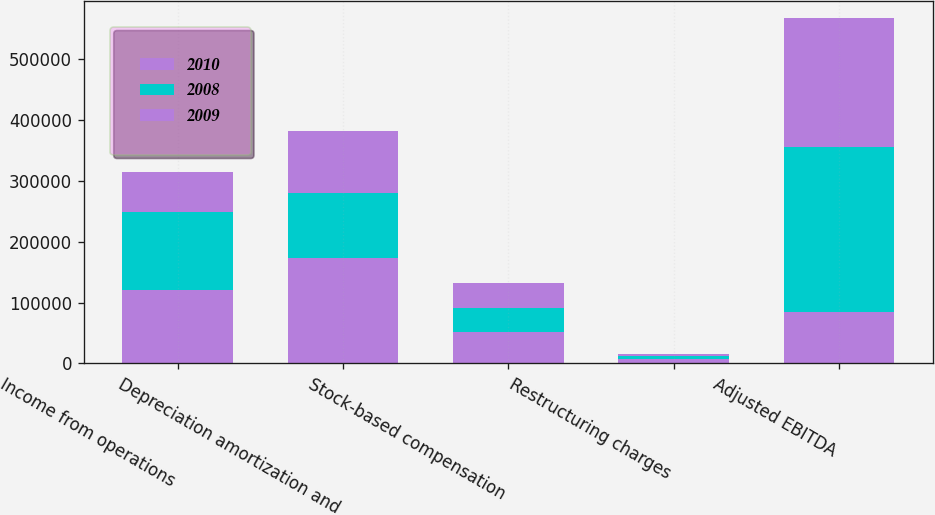Convert chart to OTSL. <chart><loc_0><loc_0><loc_500><loc_500><stacked_bar_chart><ecel><fcel>Income from operations<fcel>Depreciation amortization and<fcel>Stock-based compensation<fcel>Restructuring charges<fcel>Adjusted EBITDA<nl><fcel>2010<fcel>121118<fcel>173811<fcel>50966<fcel>6734<fcel>83808<nl><fcel>2008<fcel>128168<fcel>106207<fcel>40082<fcel>6053<fcel>272495<nl><fcel>2009<fcel>66202<fcel>101414<fcel>40993<fcel>3142<fcel>211751<nl></chart> 